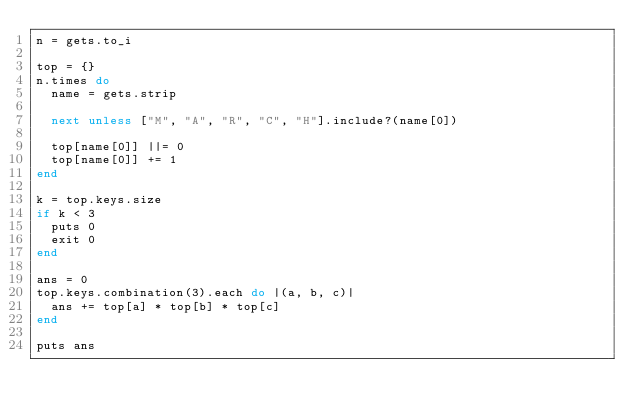Convert code to text. <code><loc_0><loc_0><loc_500><loc_500><_Ruby_>n = gets.to_i

top = {}
n.times do
  name = gets.strip

  next unless ["M", "A", "R", "C", "H"].include?(name[0])
  
  top[name[0]] ||= 0
  top[name[0]] += 1
end

k = top.keys.size
if k < 3
  puts 0
  exit 0
end

ans = 0
top.keys.combination(3).each do |(a, b, c)|
  ans += top[a] * top[b] * top[c]
end

puts ans
</code> 